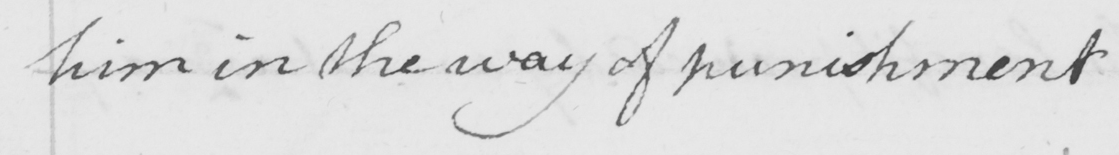Transcribe the text shown in this historical manuscript line. him in the way of punishment 